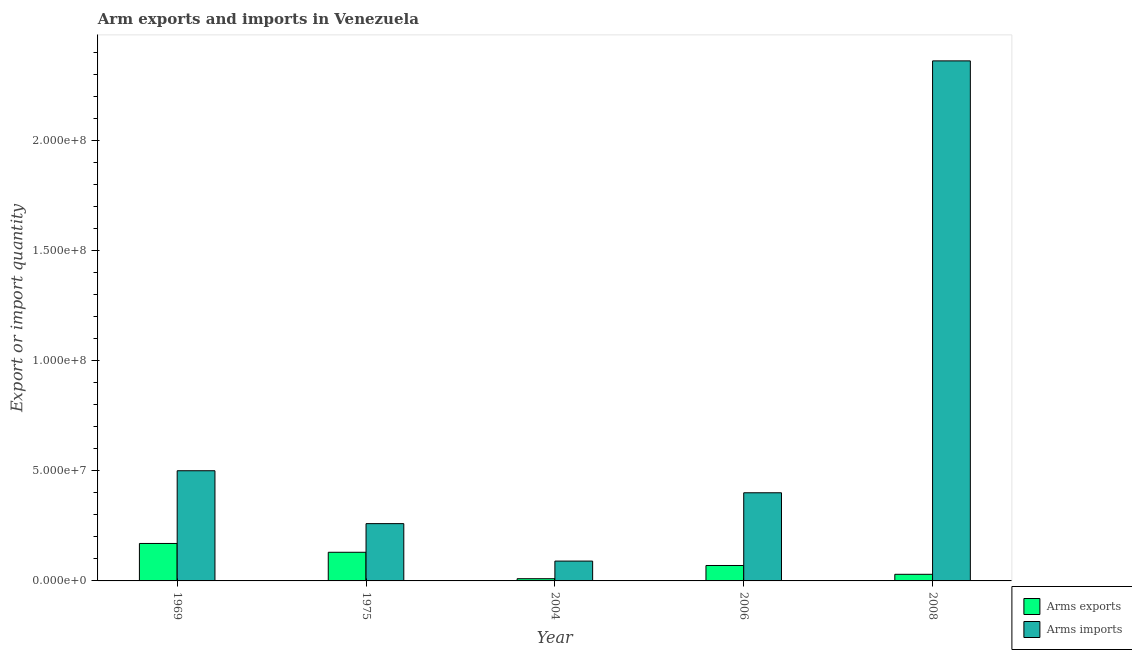How many different coloured bars are there?
Ensure brevity in your answer.  2. How many groups of bars are there?
Your response must be concise. 5. Are the number of bars per tick equal to the number of legend labels?
Make the answer very short. Yes. How many bars are there on the 3rd tick from the left?
Offer a terse response. 2. What is the label of the 4th group of bars from the left?
Offer a terse response. 2006. What is the arms imports in 2008?
Your response must be concise. 2.36e+08. Across all years, what is the maximum arms exports?
Provide a succinct answer. 1.70e+07. Across all years, what is the minimum arms exports?
Ensure brevity in your answer.  1.00e+06. In which year was the arms exports maximum?
Provide a succinct answer. 1969. In which year was the arms imports minimum?
Provide a succinct answer. 2004. What is the total arms exports in the graph?
Offer a terse response. 4.10e+07. What is the difference between the arms exports in 1969 and that in 2004?
Keep it short and to the point. 1.60e+07. What is the difference between the arms imports in 1969 and the arms exports in 2006?
Keep it short and to the point. 1.00e+07. What is the average arms exports per year?
Your answer should be compact. 8.20e+06. In the year 2006, what is the difference between the arms imports and arms exports?
Your answer should be compact. 0. In how many years, is the arms imports greater than 40000000?
Your response must be concise. 2. What is the ratio of the arms imports in 1975 to that in 2008?
Your response must be concise. 0.11. What is the difference between the highest and the second highest arms imports?
Make the answer very short. 1.86e+08. What is the difference between the highest and the lowest arms imports?
Offer a very short reply. 2.27e+08. In how many years, is the arms exports greater than the average arms exports taken over all years?
Make the answer very short. 2. What does the 2nd bar from the left in 1975 represents?
Give a very brief answer. Arms imports. What does the 2nd bar from the right in 1969 represents?
Offer a terse response. Arms exports. Are all the bars in the graph horizontal?
Your answer should be very brief. No. How many years are there in the graph?
Ensure brevity in your answer.  5. Does the graph contain grids?
Ensure brevity in your answer.  No. Where does the legend appear in the graph?
Provide a succinct answer. Bottom right. How many legend labels are there?
Your response must be concise. 2. What is the title of the graph?
Offer a terse response. Arm exports and imports in Venezuela. What is the label or title of the Y-axis?
Provide a short and direct response. Export or import quantity. What is the Export or import quantity of Arms exports in 1969?
Keep it short and to the point. 1.70e+07. What is the Export or import quantity of Arms imports in 1969?
Offer a terse response. 5.00e+07. What is the Export or import quantity of Arms exports in 1975?
Your answer should be very brief. 1.30e+07. What is the Export or import quantity of Arms imports in 1975?
Provide a succinct answer. 2.60e+07. What is the Export or import quantity in Arms imports in 2004?
Offer a very short reply. 9.00e+06. What is the Export or import quantity of Arms exports in 2006?
Provide a short and direct response. 7.00e+06. What is the Export or import quantity in Arms imports in 2006?
Provide a succinct answer. 4.00e+07. What is the Export or import quantity in Arms exports in 2008?
Your answer should be compact. 3.00e+06. What is the Export or import quantity in Arms imports in 2008?
Ensure brevity in your answer.  2.36e+08. Across all years, what is the maximum Export or import quantity of Arms exports?
Provide a succinct answer. 1.70e+07. Across all years, what is the maximum Export or import quantity in Arms imports?
Offer a terse response. 2.36e+08. Across all years, what is the minimum Export or import quantity of Arms exports?
Offer a very short reply. 1.00e+06. Across all years, what is the minimum Export or import quantity in Arms imports?
Ensure brevity in your answer.  9.00e+06. What is the total Export or import quantity in Arms exports in the graph?
Keep it short and to the point. 4.10e+07. What is the total Export or import quantity of Arms imports in the graph?
Keep it short and to the point. 3.61e+08. What is the difference between the Export or import quantity of Arms exports in 1969 and that in 1975?
Your response must be concise. 4.00e+06. What is the difference between the Export or import quantity of Arms imports in 1969 and that in 1975?
Your answer should be very brief. 2.40e+07. What is the difference between the Export or import quantity in Arms exports in 1969 and that in 2004?
Offer a very short reply. 1.60e+07. What is the difference between the Export or import quantity of Arms imports in 1969 and that in 2004?
Give a very brief answer. 4.10e+07. What is the difference between the Export or import quantity of Arms imports in 1969 and that in 2006?
Your answer should be compact. 1.00e+07. What is the difference between the Export or import quantity in Arms exports in 1969 and that in 2008?
Your answer should be very brief. 1.40e+07. What is the difference between the Export or import quantity in Arms imports in 1969 and that in 2008?
Your answer should be compact. -1.86e+08. What is the difference between the Export or import quantity in Arms imports in 1975 and that in 2004?
Your response must be concise. 1.70e+07. What is the difference between the Export or import quantity of Arms imports in 1975 and that in 2006?
Your answer should be compact. -1.40e+07. What is the difference between the Export or import quantity of Arms exports in 1975 and that in 2008?
Your answer should be very brief. 1.00e+07. What is the difference between the Export or import quantity of Arms imports in 1975 and that in 2008?
Your answer should be compact. -2.10e+08. What is the difference between the Export or import quantity of Arms exports in 2004 and that in 2006?
Offer a terse response. -6.00e+06. What is the difference between the Export or import quantity of Arms imports in 2004 and that in 2006?
Offer a very short reply. -3.10e+07. What is the difference between the Export or import quantity in Arms exports in 2004 and that in 2008?
Make the answer very short. -2.00e+06. What is the difference between the Export or import quantity in Arms imports in 2004 and that in 2008?
Offer a very short reply. -2.27e+08. What is the difference between the Export or import quantity in Arms imports in 2006 and that in 2008?
Provide a short and direct response. -1.96e+08. What is the difference between the Export or import quantity of Arms exports in 1969 and the Export or import quantity of Arms imports in 1975?
Provide a short and direct response. -9.00e+06. What is the difference between the Export or import quantity of Arms exports in 1969 and the Export or import quantity of Arms imports in 2006?
Your response must be concise. -2.30e+07. What is the difference between the Export or import quantity in Arms exports in 1969 and the Export or import quantity in Arms imports in 2008?
Ensure brevity in your answer.  -2.19e+08. What is the difference between the Export or import quantity of Arms exports in 1975 and the Export or import quantity of Arms imports in 2004?
Provide a succinct answer. 4.00e+06. What is the difference between the Export or import quantity in Arms exports in 1975 and the Export or import quantity in Arms imports in 2006?
Give a very brief answer. -2.70e+07. What is the difference between the Export or import quantity of Arms exports in 1975 and the Export or import quantity of Arms imports in 2008?
Give a very brief answer. -2.23e+08. What is the difference between the Export or import quantity of Arms exports in 2004 and the Export or import quantity of Arms imports in 2006?
Give a very brief answer. -3.90e+07. What is the difference between the Export or import quantity in Arms exports in 2004 and the Export or import quantity in Arms imports in 2008?
Your answer should be very brief. -2.35e+08. What is the difference between the Export or import quantity in Arms exports in 2006 and the Export or import quantity in Arms imports in 2008?
Your response must be concise. -2.29e+08. What is the average Export or import quantity in Arms exports per year?
Offer a very short reply. 8.20e+06. What is the average Export or import quantity of Arms imports per year?
Offer a very short reply. 7.22e+07. In the year 1969, what is the difference between the Export or import quantity of Arms exports and Export or import quantity of Arms imports?
Provide a short and direct response. -3.30e+07. In the year 1975, what is the difference between the Export or import quantity in Arms exports and Export or import quantity in Arms imports?
Give a very brief answer. -1.30e+07. In the year 2004, what is the difference between the Export or import quantity in Arms exports and Export or import quantity in Arms imports?
Provide a succinct answer. -8.00e+06. In the year 2006, what is the difference between the Export or import quantity of Arms exports and Export or import quantity of Arms imports?
Offer a very short reply. -3.30e+07. In the year 2008, what is the difference between the Export or import quantity in Arms exports and Export or import quantity in Arms imports?
Give a very brief answer. -2.33e+08. What is the ratio of the Export or import quantity of Arms exports in 1969 to that in 1975?
Provide a succinct answer. 1.31. What is the ratio of the Export or import quantity of Arms imports in 1969 to that in 1975?
Ensure brevity in your answer.  1.92. What is the ratio of the Export or import quantity in Arms exports in 1969 to that in 2004?
Give a very brief answer. 17. What is the ratio of the Export or import quantity in Arms imports in 1969 to that in 2004?
Your answer should be very brief. 5.56. What is the ratio of the Export or import quantity in Arms exports in 1969 to that in 2006?
Your answer should be compact. 2.43. What is the ratio of the Export or import quantity of Arms exports in 1969 to that in 2008?
Make the answer very short. 5.67. What is the ratio of the Export or import quantity in Arms imports in 1969 to that in 2008?
Make the answer very short. 0.21. What is the ratio of the Export or import quantity in Arms imports in 1975 to that in 2004?
Provide a succinct answer. 2.89. What is the ratio of the Export or import quantity in Arms exports in 1975 to that in 2006?
Offer a very short reply. 1.86. What is the ratio of the Export or import quantity of Arms imports in 1975 to that in 2006?
Provide a short and direct response. 0.65. What is the ratio of the Export or import quantity in Arms exports in 1975 to that in 2008?
Your response must be concise. 4.33. What is the ratio of the Export or import quantity of Arms imports in 1975 to that in 2008?
Your answer should be very brief. 0.11. What is the ratio of the Export or import quantity of Arms exports in 2004 to that in 2006?
Your answer should be very brief. 0.14. What is the ratio of the Export or import quantity of Arms imports in 2004 to that in 2006?
Ensure brevity in your answer.  0.23. What is the ratio of the Export or import quantity of Arms imports in 2004 to that in 2008?
Provide a succinct answer. 0.04. What is the ratio of the Export or import quantity of Arms exports in 2006 to that in 2008?
Your answer should be very brief. 2.33. What is the ratio of the Export or import quantity of Arms imports in 2006 to that in 2008?
Offer a very short reply. 0.17. What is the difference between the highest and the second highest Export or import quantity of Arms imports?
Your answer should be compact. 1.86e+08. What is the difference between the highest and the lowest Export or import quantity in Arms exports?
Ensure brevity in your answer.  1.60e+07. What is the difference between the highest and the lowest Export or import quantity in Arms imports?
Ensure brevity in your answer.  2.27e+08. 